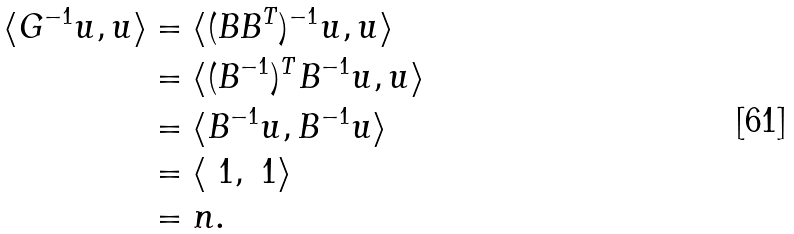Convert formula to latex. <formula><loc_0><loc_0><loc_500><loc_500>\langle G ^ { - 1 } u , u \rangle & = \langle ( B B ^ { T } ) ^ { - 1 } u , u \rangle \\ & = \langle ( B ^ { - 1 } ) ^ { T } B ^ { - 1 } u , u \rangle \\ & = \langle B ^ { - 1 } u , B ^ { - 1 } u \rangle \\ & = \langle \ 1 , \ 1 \rangle \\ & = n .</formula> 